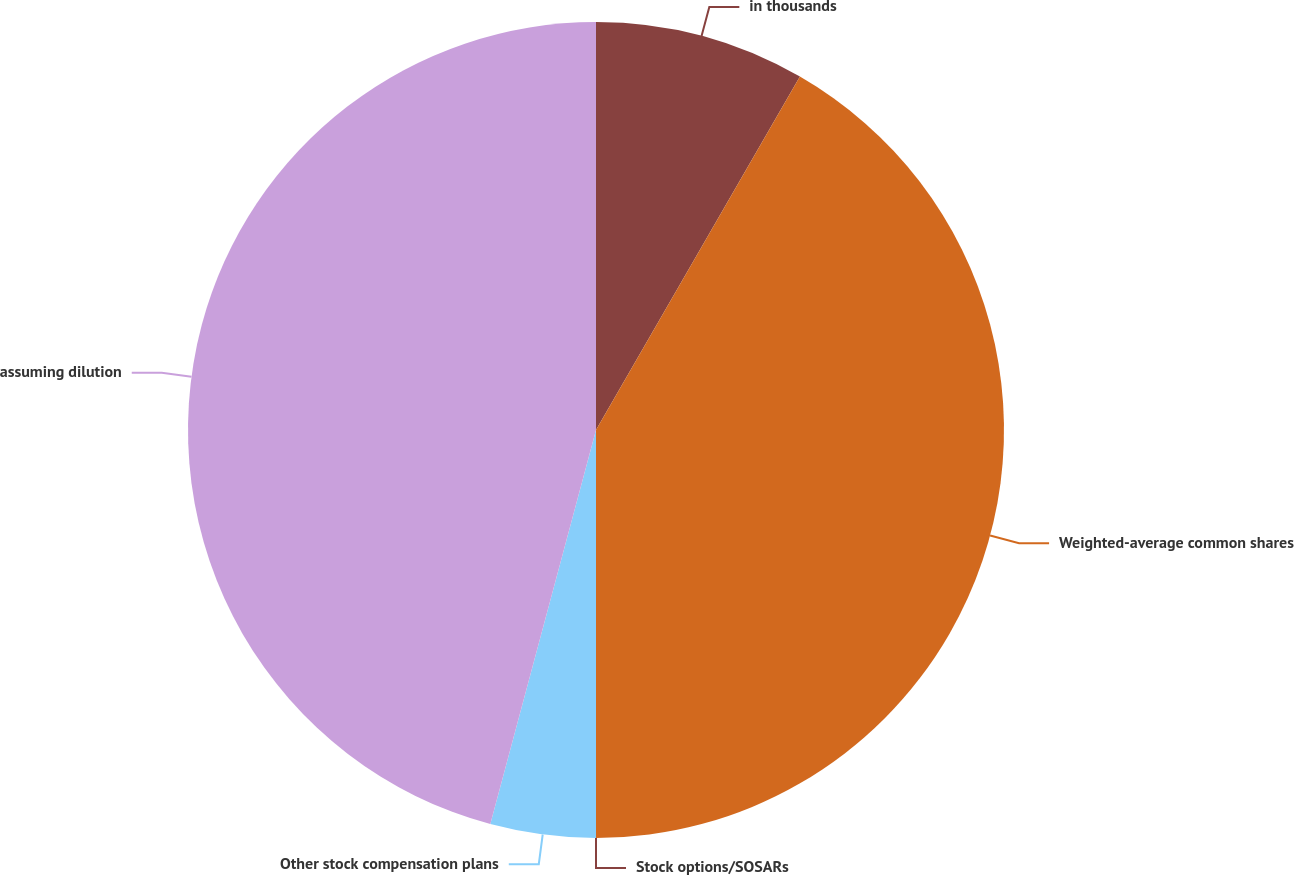Convert chart to OTSL. <chart><loc_0><loc_0><loc_500><loc_500><pie_chart><fcel>in thousands<fcel>Weighted-average common shares<fcel>Stock options/SOSARs<fcel>Other stock compensation plans<fcel>assuming dilution<nl><fcel>8.33%<fcel>41.67%<fcel>0.0%<fcel>4.17%<fcel>45.83%<nl></chart> 